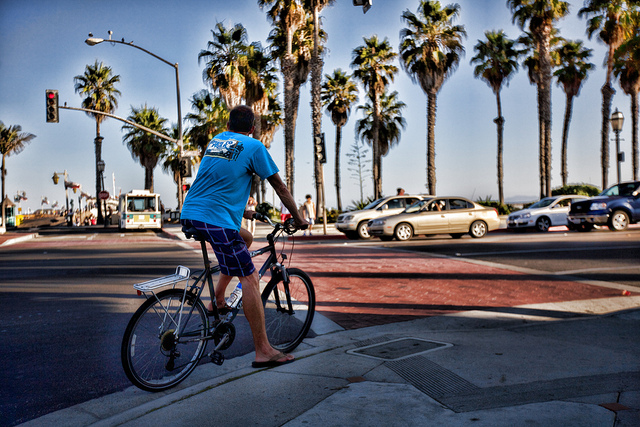What kind of transportation is shown?
A. air
B. road
C. rail
D. water
Answer with the option's letter from the given choices directly. B 